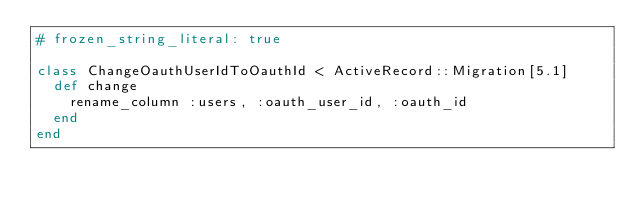<code> <loc_0><loc_0><loc_500><loc_500><_Ruby_># frozen_string_literal: true

class ChangeOauthUserIdToOauthId < ActiveRecord::Migration[5.1]
  def change
    rename_column :users, :oauth_user_id, :oauth_id
  end
end
</code> 